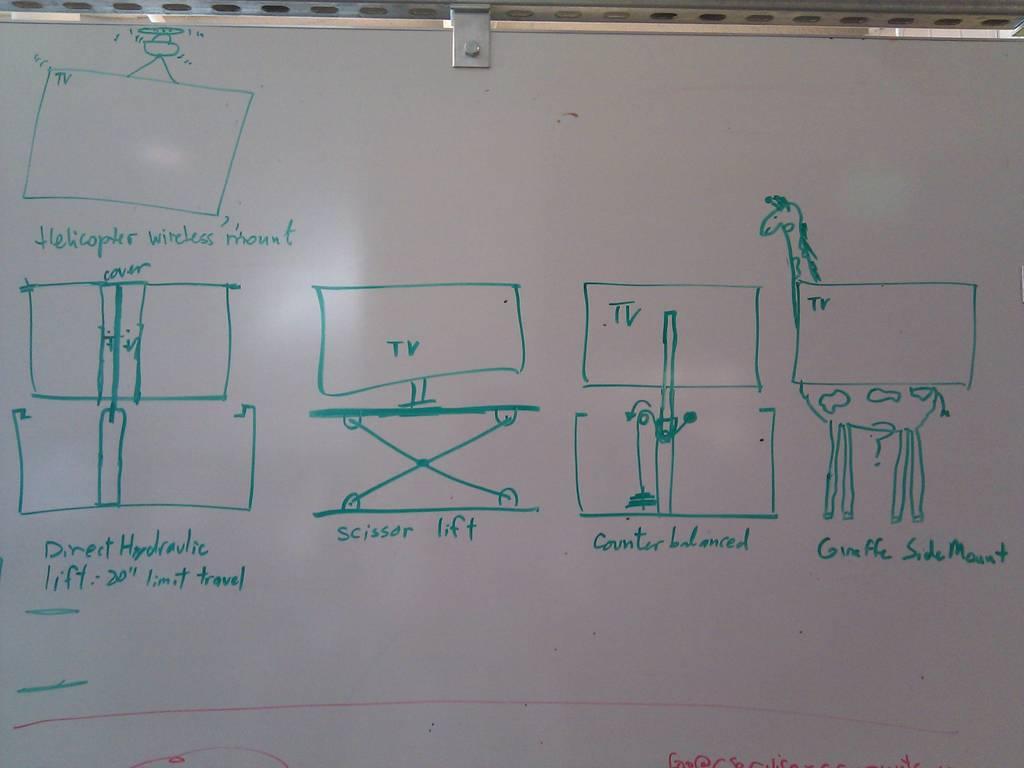What is the 2nd tv stand from the left called?
Make the answer very short. Scissor lift. 